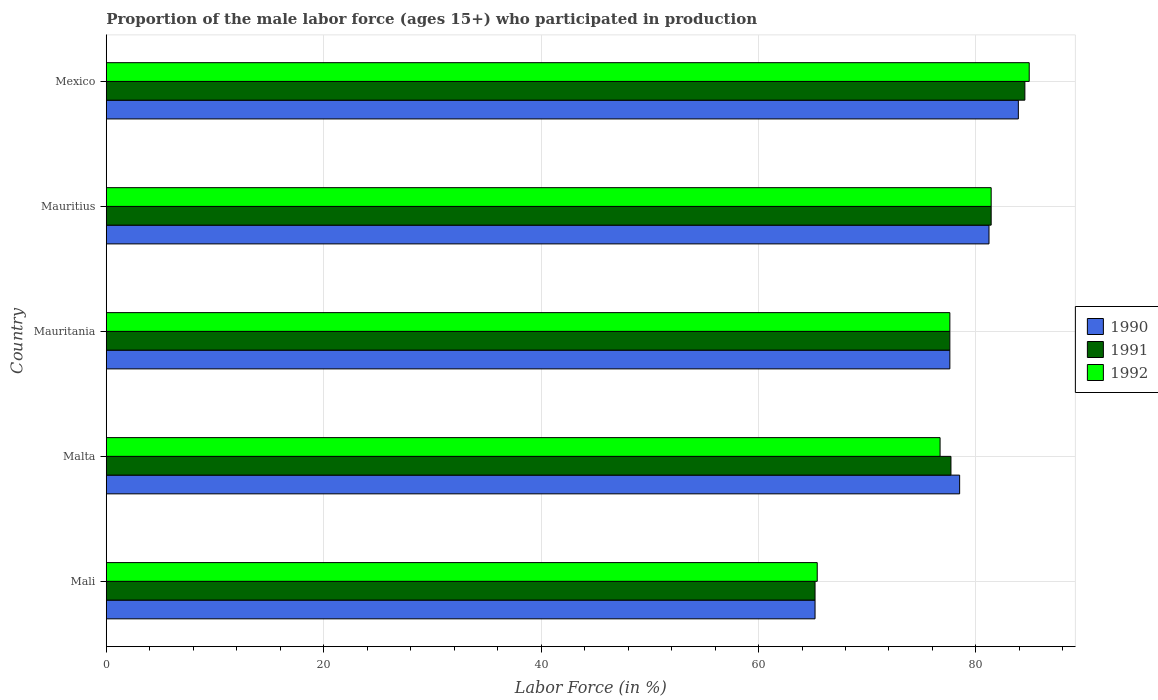Are the number of bars per tick equal to the number of legend labels?
Your answer should be compact. Yes. What is the label of the 2nd group of bars from the top?
Provide a succinct answer. Mauritius. In how many cases, is the number of bars for a given country not equal to the number of legend labels?
Provide a short and direct response. 0. What is the proportion of the male labor force who participated in production in 1992 in Malta?
Make the answer very short. 76.7. Across all countries, what is the maximum proportion of the male labor force who participated in production in 1992?
Ensure brevity in your answer.  84.9. Across all countries, what is the minimum proportion of the male labor force who participated in production in 1992?
Ensure brevity in your answer.  65.4. In which country was the proportion of the male labor force who participated in production in 1992 maximum?
Make the answer very short. Mexico. In which country was the proportion of the male labor force who participated in production in 1992 minimum?
Your answer should be compact. Mali. What is the total proportion of the male labor force who participated in production in 1991 in the graph?
Offer a terse response. 386.4. What is the difference between the proportion of the male labor force who participated in production in 1992 in Mali and that in Mexico?
Ensure brevity in your answer.  -19.5. What is the difference between the proportion of the male labor force who participated in production in 1992 in Malta and the proportion of the male labor force who participated in production in 1990 in Mexico?
Ensure brevity in your answer.  -7.2. What is the average proportion of the male labor force who participated in production in 1992 per country?
Your answer should be compact. 77.2. What is the difference between the proportion of the male labor force who participated in production in 1992 and proportion of the male labor force who participated in production in 1991 in Mexico?
Give a very brief answer. 0.4. In how many countries, is the proportion of the male labor force who participated in production in 1991 greater than 4 %?
Offer a very short reply. 5. What is the ratio of the proportion of the male labor force who participated in production in 1991 in Mali to that in Mexico?
Offer a very short reply. 0.77. Is the proportion of the male labor force who participated in production in 1991 in Mali less than that in Malta?
Give a very brief answer. Yes. What is the difference between the highest and the second highest proportion of the male labor force who participated in production in 1992?
Give a very brief answer. 3.5. What is the difference between the highest and the lowest proportion of the male labor force who participated in production in 1992?
Your answer should be very brief. 19.5. In how many countries, is the proportion of the male labor force who participated in production in 1991 greater than the average proportion of the male labor force who participated in production in 1991 taken over all countries?
Offer a very short reply. 4. What does the 2nd bar from the top in Mauritania represents?
Your answer should be very brief. 1991. Is it the case that in every country, the sum of the proportion of the male labor force who participated in production in 1992 and proportion of the male labor force who participated in production in 1991 is greater than the proportion of the male labor force who participated in production in 1990?
Offer a terse response. Yes. Are the values on the major ticks of X-axis written in scientific E-notation?
Provide a succinct answer. No. Does the graph contain grids?
Your answer should be compact. Yes. Where does the legend appear in the graph?
Give a very brief answer. Center right. How are the legend labels stacked?
Your answer should be compact. Vertical. What is the title of the graph?
Offer a terse response. Proportion of the male labor force (ages 15+) who participated in production. What is the label or title of the X-axis?
Offer a terse response. Labor Force (in %). What is the Labor Force (in %) in 1990 in Mali?
Your response must be concise. 65.2. What is the Labor Force (in %) in 1991 in Mali?
Provide a short and direct response. 65.2. What is the Labor Force (in %) of 1992 in Mali?
Your answer should be compact. 65.4. What is the Labor Force (in %) of 1990 in Malta?
Give a very brief answer. 78.5. What is the Labor Force (in %) in 1991 in Malta?
Provide a short and direct response. 77.7. What is the Labor Force (in %) of 1992 in Malta?
Keep it short and to the point. 76.7. What is the Labor Force (in %) of 1990 in Mauritania?
Your answer should be very brief. 77.6. What is the Labor Force (in %) of 1991 in Mauritania?
Provide a short and direct response. 77.6. What is the Labor Force (in %) of 1992 in Mauritania?
Your answer should be compact. 77.6. What is the Labor Force (in %) in 1990 in Mauritius?
Provide a short and direct response. 81.2. What is the Labor Force (in %) of 1991 in Mauritius?
Your answer should be very brief. 81.4. What is the Labor Force (in %) in 1992 in Mauritius?
Keep it short and to the point. 81.4. What is the Labor Force (in %) in 1990 in Mexico?
Make the answer very short. 83.9. What is the Labor Force (in %) in 1991 in Mexico?
Keep it short and to the point. 84.5. What is the Labor Force (in %) in 1992 in Mexico?
Your response must be concise. 84.9. Across all countries, what is the maximum Labor Force (in %) of 1990?
Provide a succinct answer. 83.9. Across all countries, what is the maximum Labor Force (in %) of 1991?
Your answer should be compact. 84.5. Across all countries, what is the maximum Labor Force (in %) in 1992?
Provide a short and direct response. 84.9. Across all countries, what is the minimum Labor Force (in %) of 1990?
Provide a succinct answer. 65.2. Across all countries, what is the minimum Labor Force (in %) of 1991?
Your answer should be compact. 65.2. Across all countries, what is the minimum Labor Force (in %) in 1992?
Keep it short and to the point. 65.4. What is the total Labor Force (in %) in 1990 in the graph?
Provide a short and direct response. 386.4. What is the total Labor Force (in %) in 1991 in the graph?
Keep it short and to the point. 386.4. What is the total Labor Force (in %) of 1992 in the graph?
Keep it short and to the point. 386. What is the difference between the Labor Force (in %) in 1990 in Mali and that in Malta?
Offer a terse response. -13.3. What is the difference between the Labor Force (in %) of 1991 in Mali and that in Malta?
Offer a terse response. -12.5. What is the difference between the Labor Force (in %) in 1990 in Mali and that in Mauritania?
Your answer should be very brief. -12.4. What is the difference between the Labor Force (in %) of 1991 in Mali and that in Mauritius?
Provide a short and direct response. -16.2. What is the difference between the Labor Force (in %) in 1992 in Mali and that in Mauritius?
Ensure brevity in your answer.  -16. What is the difference between the Labor Force (in %) of 1990 in Mali and that in Mexico?
Make the answer very short. -18.7. What is the difference between the Labor Force (in %) in 1991 in Mali and that in Mexico?
Offer a very short reply. -19.3. What is the difference between the Labor Force (in %) in 1992 in Mali and that in Mexico?
Your answer should be compact. -19.5. What is the difference between the Labor Force (in %) of 1991 in Malta and that in Mauritania?
Your answer should be compact. 0.1. What is the difference between the Labor Force (in %) in 1992 in Malta and that in Mauritania?
Offer a terse response. -0.9. What is the difference between the Labor Force (in %) in 1990 in Malta and that in Mauritius?
Offer a very short reply. -2.7. What is the difference between the Labor Force (in %) in 1991 in Malta and that in Mauritius?
Your answer should be compact. -3.7. What is the difference between the Labor Force (in %) in 1992 in Malta and that in Mauritius?
Your response must be concise. -4.7. What is the difference between the Labor Force (in %) of 1990 in Mauritania and that in Mauritius?
Provide a short and direct response. -3.6. What is the difference between the Labor Force (in %) in 1991 in Mauritania and that in Mexico?
Offer a very short reply. -6.9. What is the difference between the Labor Force (in %) in 1992 in Mauritania and that in Mexico?
Offer a very short reply. -7.3. What is the difference between the Labor Force (in %) of 1992 in Mauritius and that in Mexico?
Provide a short and direct response. -3.5. What is the difference between the Labor Force (in %) of 1990 in Mali and the Labor Force (in %) of 1991 in Malta?
Your response must be concise. -12.5. What is the difference between the Labor Force (in %) in 1991 in Mali and the Labor Force (in %) in 1992 in Mauritania?
Offer a terse response. -12.4. What is the difference between the Labor Force (in %) in 1990 in Mali and the Labor Force (in %) in 1991 in Mauritius?
Keep it short and to the point. -16.2. What is the difference between the Labor Force (in %) of 1990 in Mali and the Labor Force (in %) of 1992 in Mauritius?
Give a very brief answer. -16.2. What is the difference between the Labor Force (in %) in 1991 in Mali and the Labor Force (in %) in 1992 in Mauritius?
Your answer should be very brief. -16.2. What is the difference between the Labor Force (in %) of 1990 in Mali and the Labor Force (in %) of 1991 in Mexico?
Provide a short and direct response. -19.3. What is the difference between the Labor Force (in %) of 1990 in Mali and the Labor Force (in %) of 1992 in Mexico?
Offer a terse response. -19.7. What is the difference between the Labor Force (in %) of 1991 in Mali and the Labor Force (in %) of 1992 in Mexico?
Give a very brief answer. -19.7. What is the difference between the Labor Force (in %) of 1990 in Malta and the Labor Force (in %) of 1991 in Mauritius?
Offer a terse response. -2.9. What is the difference between the Labor Force (in %) in 1990 in Malta and the Labor Force (in %) in 1992 in Mauritius?
Provide a short and direct response. -2.9. What is the difference between the Labor Force (in %) in 1991 in Malta and the Labor Force (in %) in 1992 in Mauritius?
Offer a very short reply. -3.7. What is the difference between the Labor Force (in %) of 1990 in Malta and the Labor Force (in %) of 1991 in Mexico?
Provide a short and direct response. -6. What is the difference between the Labor Force (in %) of 1990 in Malta and the Labor Force (in %) of 1992 in Mexico?
Your response must be concise. -6.4. What is the difference between the Labor Force (in %) in 1991 in Malta and the Labor Force (in %) in 1992 in Mexico?
Offer a terse response. -7.2. What is the difference between the Labor Force (in %) in 1990 in Mauritania and the Labor Force (in %) in 1991 in Mauritius?
Provide a succinct answer. -3.8. What is the difference between the Labor Force (in %) in 1990 in Mauritania and the Labor Force (in %) in 1992 in Mauritius?
Provide a succinct answer. -3.8. What is the difference between the Labor Force (in %) in 1990 in Mauritius and the Labor Force (in %) in 1992 in Mexico?
Keep it short and to the point. -3.7. What is the average Labor Force (in %) of 1990 per country?
Offer a very short reply. 77.28. What is the average Labor Force (in %) in 1991 per country?
Your answer should be compact. 77.28. What is the average Labor Force (in %) of 1992 per country?
Provide a succinct answer. 77.2. What is the difference between the Labor Force (in %) of 1990 and Labor Force (in %) of 1991 in Mali?
Give a very brief answer. 0. What is the difference between the Labor Force (in %) of 1990 and Labor Force (in %) of 1992 in Mali?
Provide a short and direct response. -0.2. What is the difference between the Labor Force (in %) in 1991 and Labor Force (in %) in 1992 in Mali?
Your answer should be very brief. -0.2. What is the difference between the Labor Force (in %) in 1990 and Labor Force (in %) in 1991 in Malta?
Your answer should be very brief. 0.8. What is the difference between the Labor Force (in %) of 1990 and Labor Force (in %) of 1992 in Malta?
Give a very brief answer. 1.8. What is the difference between the Labor Force (in %) in 1990 and Labor Force (in %) in 1992 in Mauritania?
Provide a short and direct response. 0. What is the difference between the Labor Force (in %) in 1991 and Labor Force (in %) in 1992 in Mauritania?
Ensure brevity in your answer.  0. What is the difference between the Labor Force (in %) of 1991 and Labor Force (in %) of 1992 in Mexico?
Keep it short and to the point. -0.4. What is the ratio of the Labor Force (in %) in 1990 in Mali to that in Malta?
Your response must be concise. 0.83. What is the ratio of the Labor Force (in %) of 1991 in Mali to that in Malta?
Offer a very short reply. 0.84. What is the ratio of the Labor Force (in %) in 1992 in Mali to that in Malta?
Your answer should be compact. 0.85. What is the ratio of the Labor Force (in %) in 1990 in Mali to that in Mauritania?
Your answer should be compact. 0.84. What is the ratio of the Labor Force (in %) in 1991 in Mali to that in Mauritania?
Ensure brevity in your answer.  0.84. What is the ratio of the Labor Force (in %) of 1992 in Mali to that in Mauritania?
Your answer should be very brief. 0.84. What is the ratio of the Labor Force (in %) of 1990 in Mali to that in Mauritius?
Give a very brief answer. 0.8. What is the ratio of the Labor Force (in %) in 1991 in Mali to that in Mauritius?
Your answer should be very brief. 0.8. What is the ratio of the Labor Force (in %) of 1992 in Mali to that in Mauritius?
Offer a very short reply. 0.8. What is the ratio of the Labor Force (in %) of 1990 in Mali to that in Mexico?
Ensure brevity in your answer.  0.78. What is the ratio of the Labor Force (in %) in 1991 in Mali to that in Mexico?
Ensure brevity in your answer.  0.77. What is the ratio of the Labor Force (in %) of 1992 in Mali to that in Mexico?
Ensure brevity in your answer.  0.77. What is the ratio of the Labor Force (in %) of 1990 in Malta to that in Mauritania?
Your answer should be compact. 1.01. What is the ratio of the Labor Force (in %) in 1992 in Malta to that in Mauritania?
Offer a very short reply. 0.99. What is the ratio of the Labor Force (in %) in 1990 in Malta to that in Mauritius?
Make the answer very short. 0.97. What is the ratio of the Labor Force (in %) in 1991 in Malta to that in Mauritius?
Make the answer very short. 0.95. What is the ratio of the Labor Force (in %) in 1992 in Malta to that in Mauritius?
Provide a succinct answer. 0.94. What is the ratio of the Labor Force (in %) of 1990 in Malta to that in Mexico?
Your response must be concise. 0.94. What is the ratio of the Labor Force (in %) of 1991 in Malta to that in Mexico?
Keep it short and to the point. 0.92. What is the ratio of the Labor Force (in %) of 1992 in Malta to that in Mexico?
Make the answer very short. 0.9. What is the ratio of the Labor Force (in %) of 1990 in Mauritania to that in Mauritius?
Ensure brevity in your answer.  0.96. What is the ratio of the Labor Force (in %) in 1991 in Mauritania to that in Mauritius?
Offer a terse response. 0.95. What is the ratio of the Labor Force (in %) in 1992 in Mauritania to that in Mauritius?
Ensure brevity in your answer.  0.95. What is the ratio of the Labor Force (in %) in 1990 in Mauritania to that in Mexico?
Provide a short and direct response. 0.92. What is the ratio of the Labor Force (in %) of 1991 in Mauritania to that in Mexico?
Keep it short and to the point. 0.92. What is the ratio of the Labor Force (in %) of 1992 in Mauritania to that in Mexico?
Provide a succinct answer. 0.91. What is the ratio of the Labor Force (in %) of 1990 in Mauritius to that in Mexico?
Your answer should be compact. 0.97. What is the ratio of the Labor Force (in %) of 1991 in Mauritius to that in Mexico?
Keep it short and to the point. 0.96. What is the ratio of the Labor Force (in %) in 1992 in Mauritius to that in Mexico?
Make the answer very short. 0.96. What is the difference between the highest and the second highest Labor Force (in %) in 1991?
Ensure brevity in your answer.  3.1. What is the difference between the highest and the second highest Labor Force (in %) of 1992?
Offer a terse response. 3.5. What is the difference between the highest and the lowest Labor Force (in %) in 1990?
Your answer should be very brief. 18.7. What is the difference between the highest and the lowest Labor Force (in %) in 1991?
Your answer should be compact. 19.3. What is the difference between the highest and the lowest Labor Force (in %) of 1992?
Your response must be concise. 19.5. 